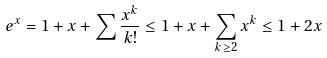Convert formula to latex. <formula><loc_0><loc_0><loc_500><loc_500>e ^ { x } = 1 + x + \sum \frac { x ^ { k } } { k ! } \leq 1 + x + \sum _ { k \geq 2 } x ^ { k } \leq 1 + 2 x</formula> 